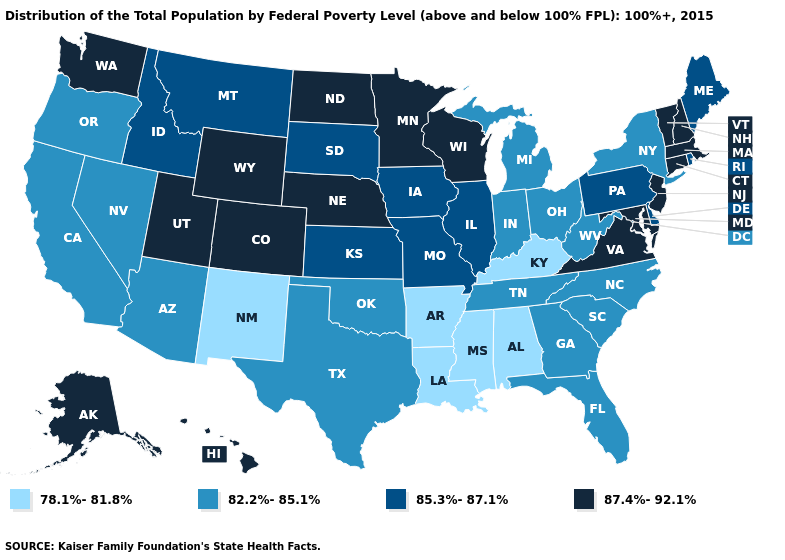Which states have the highest value in the USA?
Write a very short answer. Alaska, Colorado, Connecticut, Hawaii, Maryland, Massachusetts, Minnesota, Nebraska, New Hampshire, New Jersey, North Dakota, Utah, Vermont, Virginia, Washington, Wisconsin, Wyoming. What is the value of South Dakota?
Concise answer only. 85.3%-87.1%. Name the states that have a value in the range 78.1%-81.8%?
Concise answer only. Alabama, Arkansas, Kentucky, Louisiana, Mississippi, New Mexico. Name the states that have a value in the range 87.4%-92.1%?
Answer briefly. Alaska, Colorado, Connecticut, Hawaii, Maryland, Massachusetts, Minnesota, Nebraska, New Hampshire, New Jersey, North Dakota, Utah, Vermont, Virginia, Washington, Wisconsin, Wyoming. Does Illinois have the highest value in the USA?
Write a very short answer. No. Name the states that have a value in the range 87.4%-92.1%?
Keep it brief. Alaska, Colorado, Connecticut, Hawaii, Maryland, Massachusetts, Minnesota, Nebraska, New Hampshire, New Jersey, North Dakota, Utah, Vermont, Virginia, Washington, Wisconsin, Wyoming. What is the lowest value in the USA?
Quick response, please. 78.1%-81.8%. Name the states that have a value in the range 78.1%-81.8%?
Concise answer only. Alabama, Arkansas, Kentucky, Louisiana, Mississippi, New Mexico. Does New Mexico have the lowest value in the USA?
Write a very short answer. Yes. What is the highest value in states that border New Mexico?
Quick response, please. 87.4%-92.1%. Does Arizona have the highest value in the West?
Keep it brief. No. What is the value of Alabama?
Answer briefly. 78.1%-81.8%. What is the value of South Carolina?
Write a very short answer. 82.2%-85.1%. Name the states that have a value in the range 78.1%-81.8%?
Give a very brief answer. Alabama, Arkansas, Kentucky, Louisiana, Mississippi, New Mexico. What is the value of Rhode Island?
Write a very short answer. 85.3%-87.1%. 